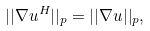<formula> <loc_0><loc_0><loc_500><loc_500>| | \nabla u ^ { H } | | _ { p } = | | \nabla u | | _ { p } ,</formula> 